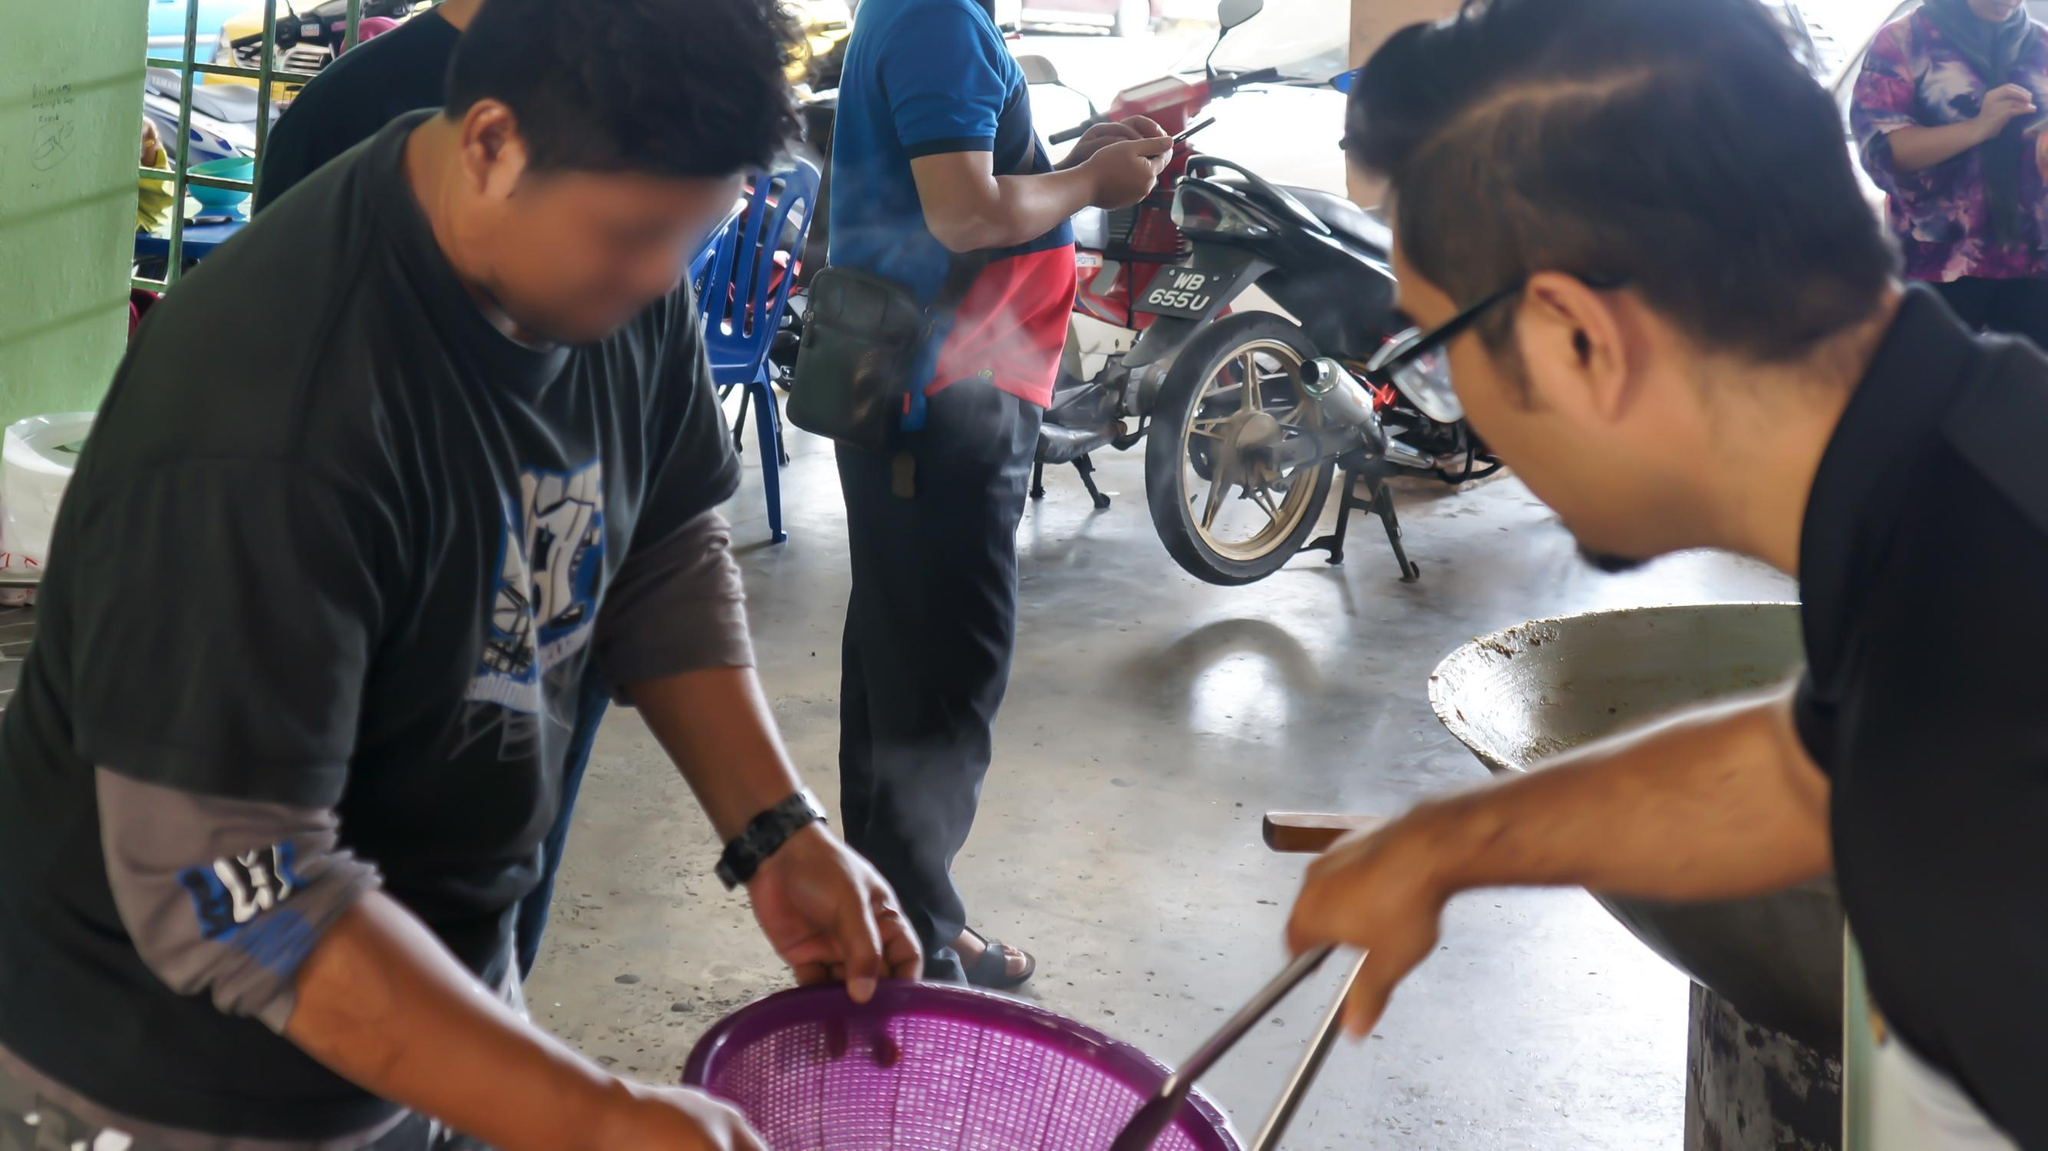What do you think is going on in this snapshot? The snapshot seems to capture an everyday interaction in what appears to be an outdoor or semi-open marketplace, possibly in a Southeast Asian setting due to the attire and motorbikes in the vicinity. Two men are the main focus, with one holding a purple basket and another pointing at the object inside, likely engaging in a discussion about the product or negotiating a deal. Around them, the blur and the movement of other individuals contribute to the energetic, dynamic environment that's typical of such markets, where the hustle of vendors and customers intermingles with the bustle of passing motorbikes. 